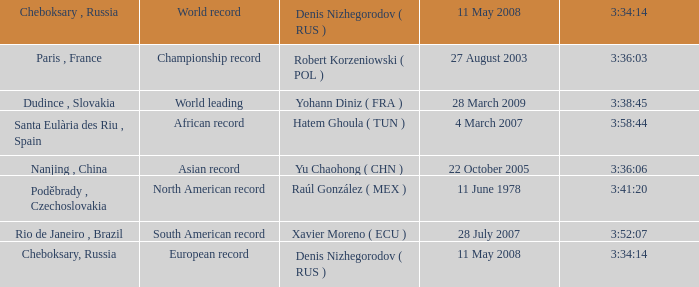When 3:38:45 is  3:34:14 what is the date on May 11th, 2008? 28 March 2009. 